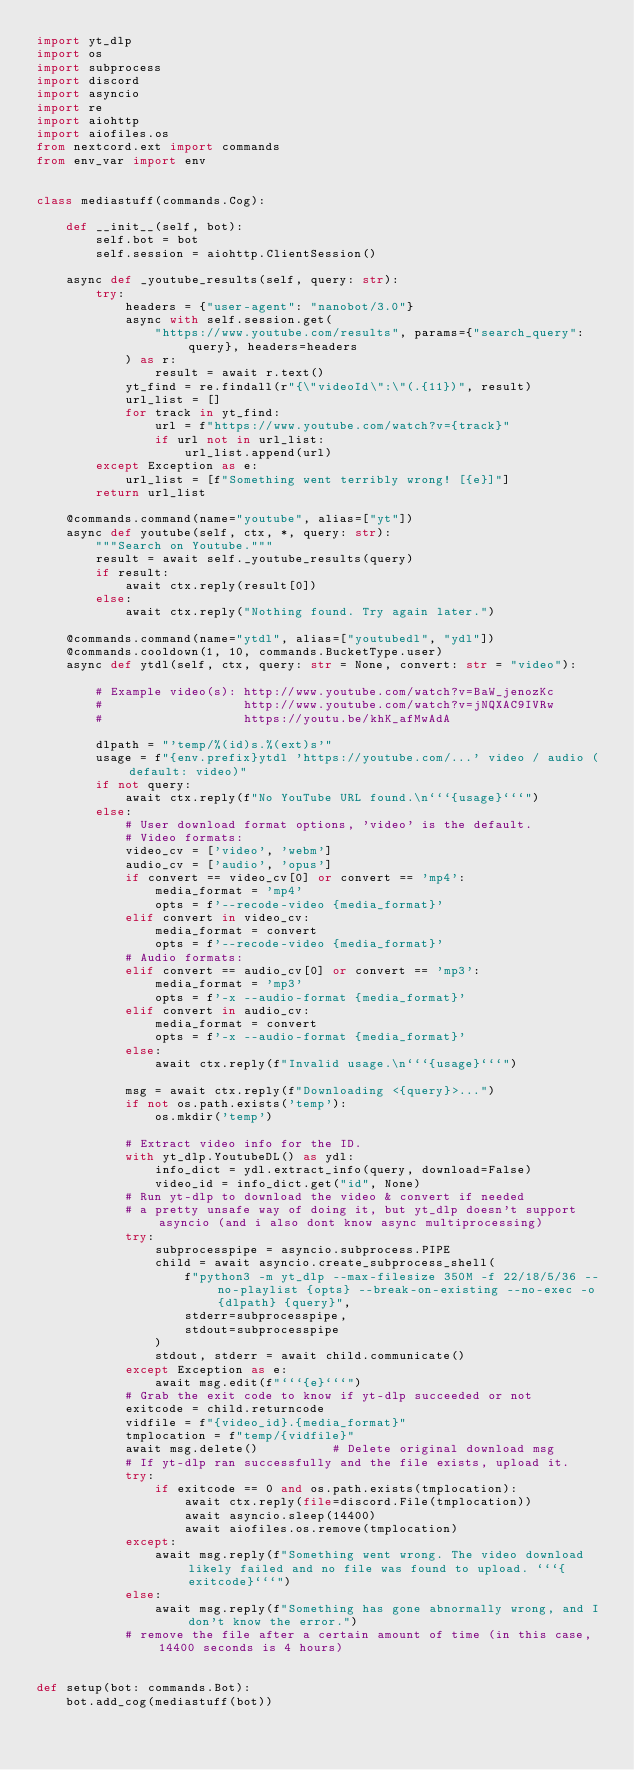<code> <loc_0><loc_0><loc_500><loc_500><_Python_>import yt_dlp
import os
import subprocess
import discord
import asyncio
import re
import aiohttp
import aiofiles.os
from nextcord.ext import commands
from env_var import env


class mediastuff(commands.Cog):

    def __init__(self, bot):
        self.bot = bot
        self.session = aiohttp.ClientSession()

    async def _youtube_results(self, query: str):
        try:
            headers = {"user-agent": "nanobot/3.0"}
            async with self.session.get(
                "https://www.youtube.com/results", params={"search_query": query}, headers=headers
            ) as r:
                result = await r.text()
            yt_find = re.findall(r"{\"videoId\":\"(.{11})", result)
            url_list = []
            for track in yt_find:
                url = f"https://www.youtube.com/watch?v={track}"
                if url not in url_list:
                    url_list.append(url)
        except Exception as e:
            url_list = [f"Something went terribly wrong! [{e}]"]
        return url_list

    @commands.command(name="youtube", alias=["yt"])
    async def youtube(self, ctx, *, query: str):
        """Search on Youtube."""
        result = await self._youtube_results(query)
        if result:
            await ctx.reply(result[0])
        else:
            await ctx.reply("Nothing found. Try again later.")

    @commands.command(name="ytdl", alias=["youtubedl", "ydl"])
    @commands.cooldown(1, 10, commands.BucketType.user)
    async def ytdl(self, ctx, query: str = None, convert: str = "video"):

        # Example video(s): http://www.youtube.com/watch?v=BaW_jenozKc
        #                   http://www.youtube.com/watch?v=jNQXAC9IVRw
        #                   https://youtu.be/khK_afMwAdA

        dlpath = "'temp/%(id)s.%(ext)s'"
        usage = f"{env.prefix}ytdl 'https://youtube.com/...' video / audio (default: video)"
        if not query:
            await ctx.reply(f"No YouTube URL found.\n```{usage}```")
        else:
            # User download format options, 'video' is the default.
            # Video formats:
            video_cv = ['video', 'webm']
            audio_cv = ['audio', 'opus']
            if convert == video_cv[0] or convert == 'mp4':
                media_format = 'mp4'
                opts = f'--recode-video {media_format}'
            elif convert in video_cv:
                media_format = convert
                opts = f'--recode-video {media_format}'
            # Audio formats:
            elif convert == audio_cv[0] or convert == 'mp3':
                media_format = 'mp3'
                opts = f'-x --audio-format {media_format}'
            elif convert in audio_cv:
                media_format = convert
                opts = f'-x --audio-format {media_format}'
            else:
                await ctx.reply(f"Invalid usage.\n```{usage}```")

            msg = await ctx.reply(f"Downloading <{query}>...")
            if not os.path.exists('temp'):
                os.mkdir('temp')

            # Extract video info for the ID.
            with yt_dlp.YoutubeDL() as ydl:
                info_dict = ydl.extract_info(query, download=False)
                video_id = info_dict.get("id", None)
            # Run yt-dlp to download the video & convert if needed
            # a pretty unsafe way of doing it, but yt_dlp doesn't support asyncio (and i also dont know async multiprocessing)
            try:
                subprocesspipe = asyncio.subprocess.PIPE
                child = await asyncio.create_subprocess_shell(
                    f"python3 -m yt_dlp --max-filesize 350M -f 22/18/5/36 --no-playlist {opts} --break-on-existing --no-exec -o {dlpath} {query}",
                    stderr=subprocesspipe,
                    stdout=subprocesspipe
                )
                stdout, stderr = await child.communicate()
            except Exception as e:
                await msg.edit(f"```{e}```")
            # Grab the exit code to know if yt-dlp succeeded or not
            exitcode = child.returncode
            vidfile = f"{video_id}.{media_format}"
            tmplocation = f"temp/{vidfile}"
            await msg.delete()          # Delete original download msg
            # If yt-dlp ran successfully and the file exists, upload it.
            try:
                if exitcode == 0 and os.path.exists(tmplocation):
                    await ctx.reply(file=discord.File(tmplocation))
                    await asyncio.sleep(14400)
                    await aiofiles.os.remove(tmplocation)
            except:
                await msg.reply(f"Something went wrong. The video download likely failed and no file was found to upload. ```{exitcode}```")
            else:
                await msg.reply(f"Something has gone abnormally wrong, and I don't know the error.")
            # remove the file after a certain amount of time (in this case, 14400 seconds is 4 hours)


def setup(bot: commands.Bot):
    bot.add_cog(mediastuff(bot))
</code> 